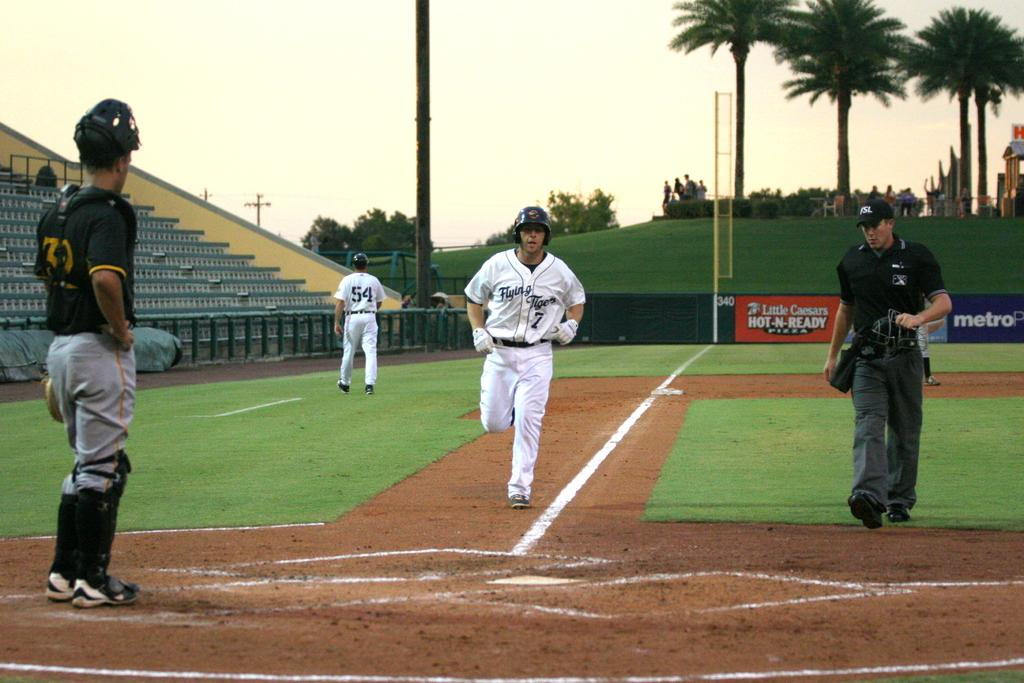<image>
Summarize the visual content of the image. A baseball player wearing a Flying Tigers uniform runs to base. 